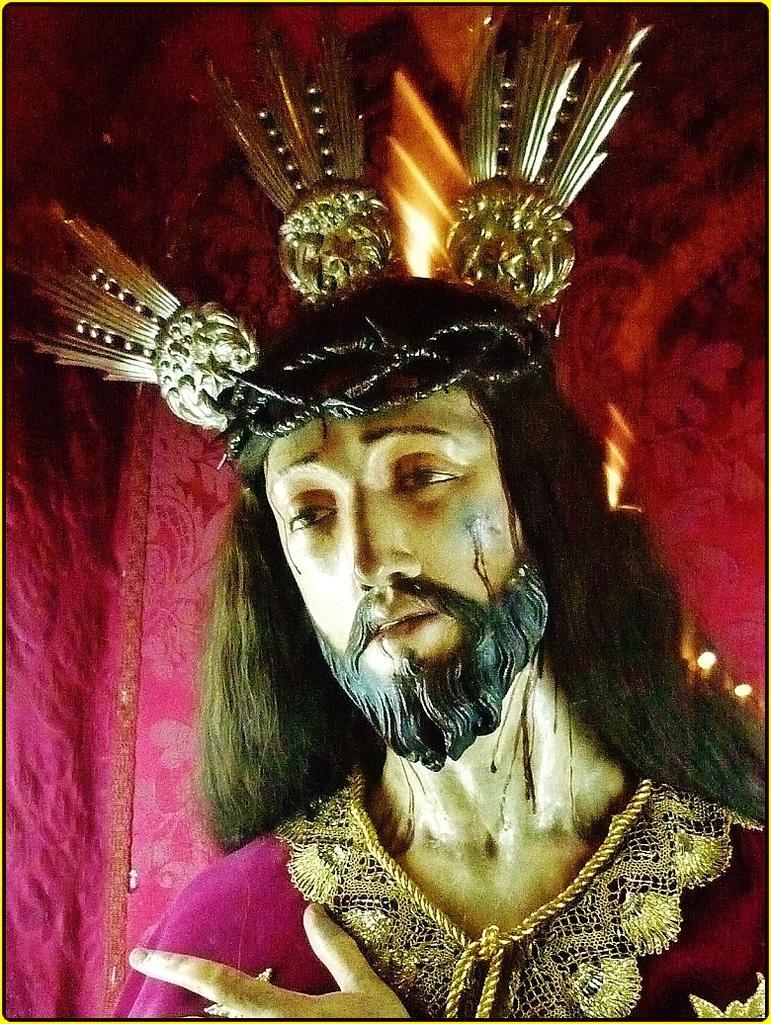Describe this image in one or two sentences. In the center of the image there is a statue. In the background of the image we can see cloth and light. 